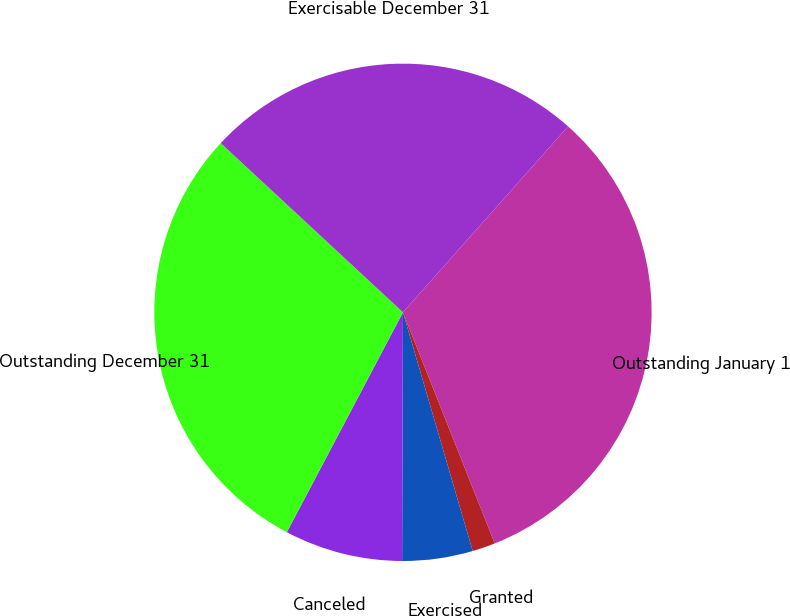<chart> <loc_0><loc_0><loc_500><loc_500><pie_chart><fcel>Outstanding January 1<fcel>Granted<fcel>Exercised<fcel>Canceled<fcel>Outstanding December 31<fcel>Exercisable December 31<nl><fcel>32.43%<fcel>1.49%<fcel>4.58%<fcel>7.68%<fcel>29.18%<fcel>24.65%<nl></chart> 